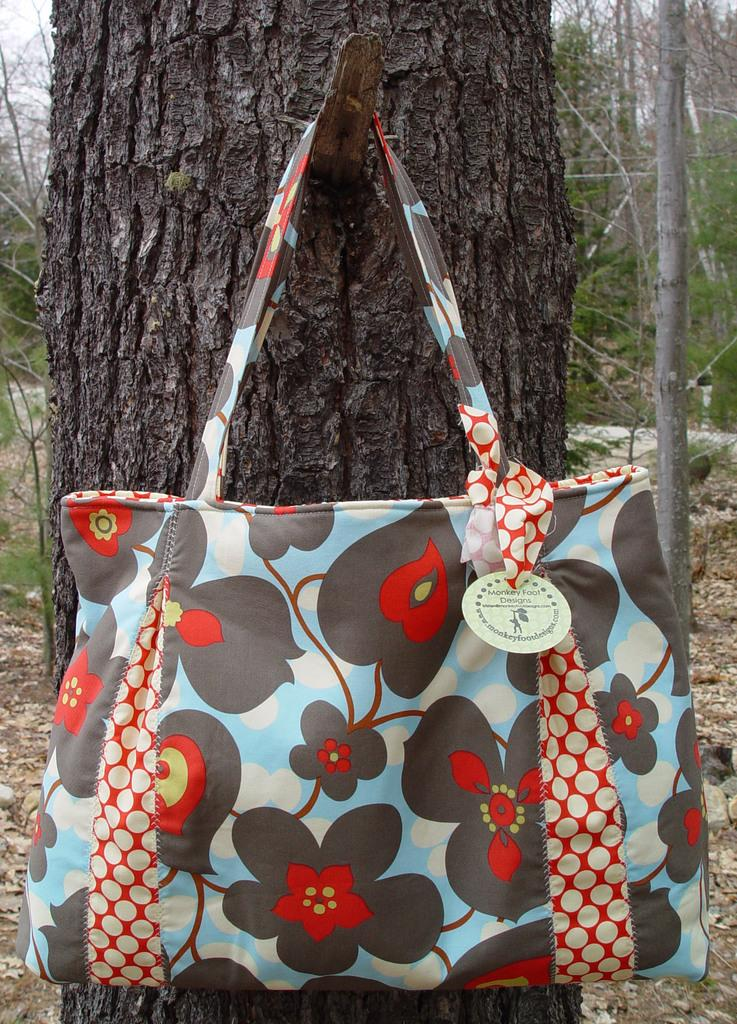What object is hanging from the tree in the image? There is a handbag in the image, and it is hanging from a tree. Can you describe the tree in the image? The tree has a trunk, and it is the one on which the handbag is hanging. What can be seen in the background of the image? Soil and other trees are visible in the background of the image. What type of juice is being squeezed from the handbag in the image? There is no juice or squeezing activity present in the image; it features a handbag hanging from a tree. Is there a volcano visible in the image? There is no volcano present in the image. 